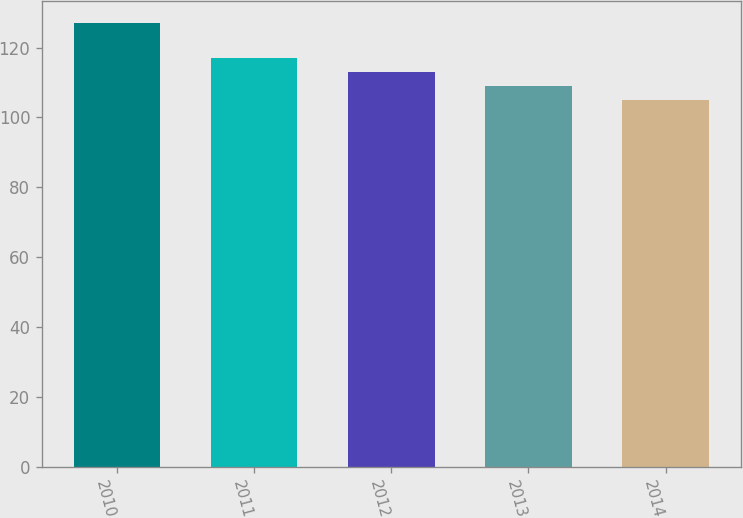Convert chart to OTSL. <chart><loc_0><loc_0><loc_500><loc_500><bar_chart><fcel>2010<fcel>2011<fcel>2012<fcel>2013<fcel>2014<nl><fcel>127<fcel>117<fcel>113<fcel>109<fcel>105<nl></chart> 